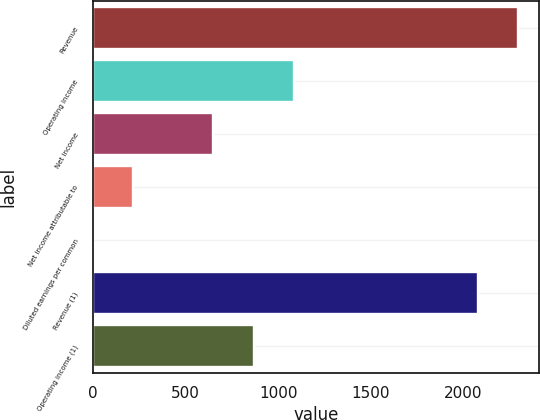Convert chart. <chart><loc_0><loc_0><loc_500><loc_500><bar_chart><fcel>Revenue<fcel>Operating income<fcel>Net income<fcel>Net income attributable to<fcel>Diluted earnings per common<fcel>Revenue (1)<fcel>Operating income (1)<nl><fcel>2294.09<fcel>1084.94<fcel>651.16<fcel>217.38<fcel>0.49<fcel>2077.2<fcel>868.05<nl></chart> 